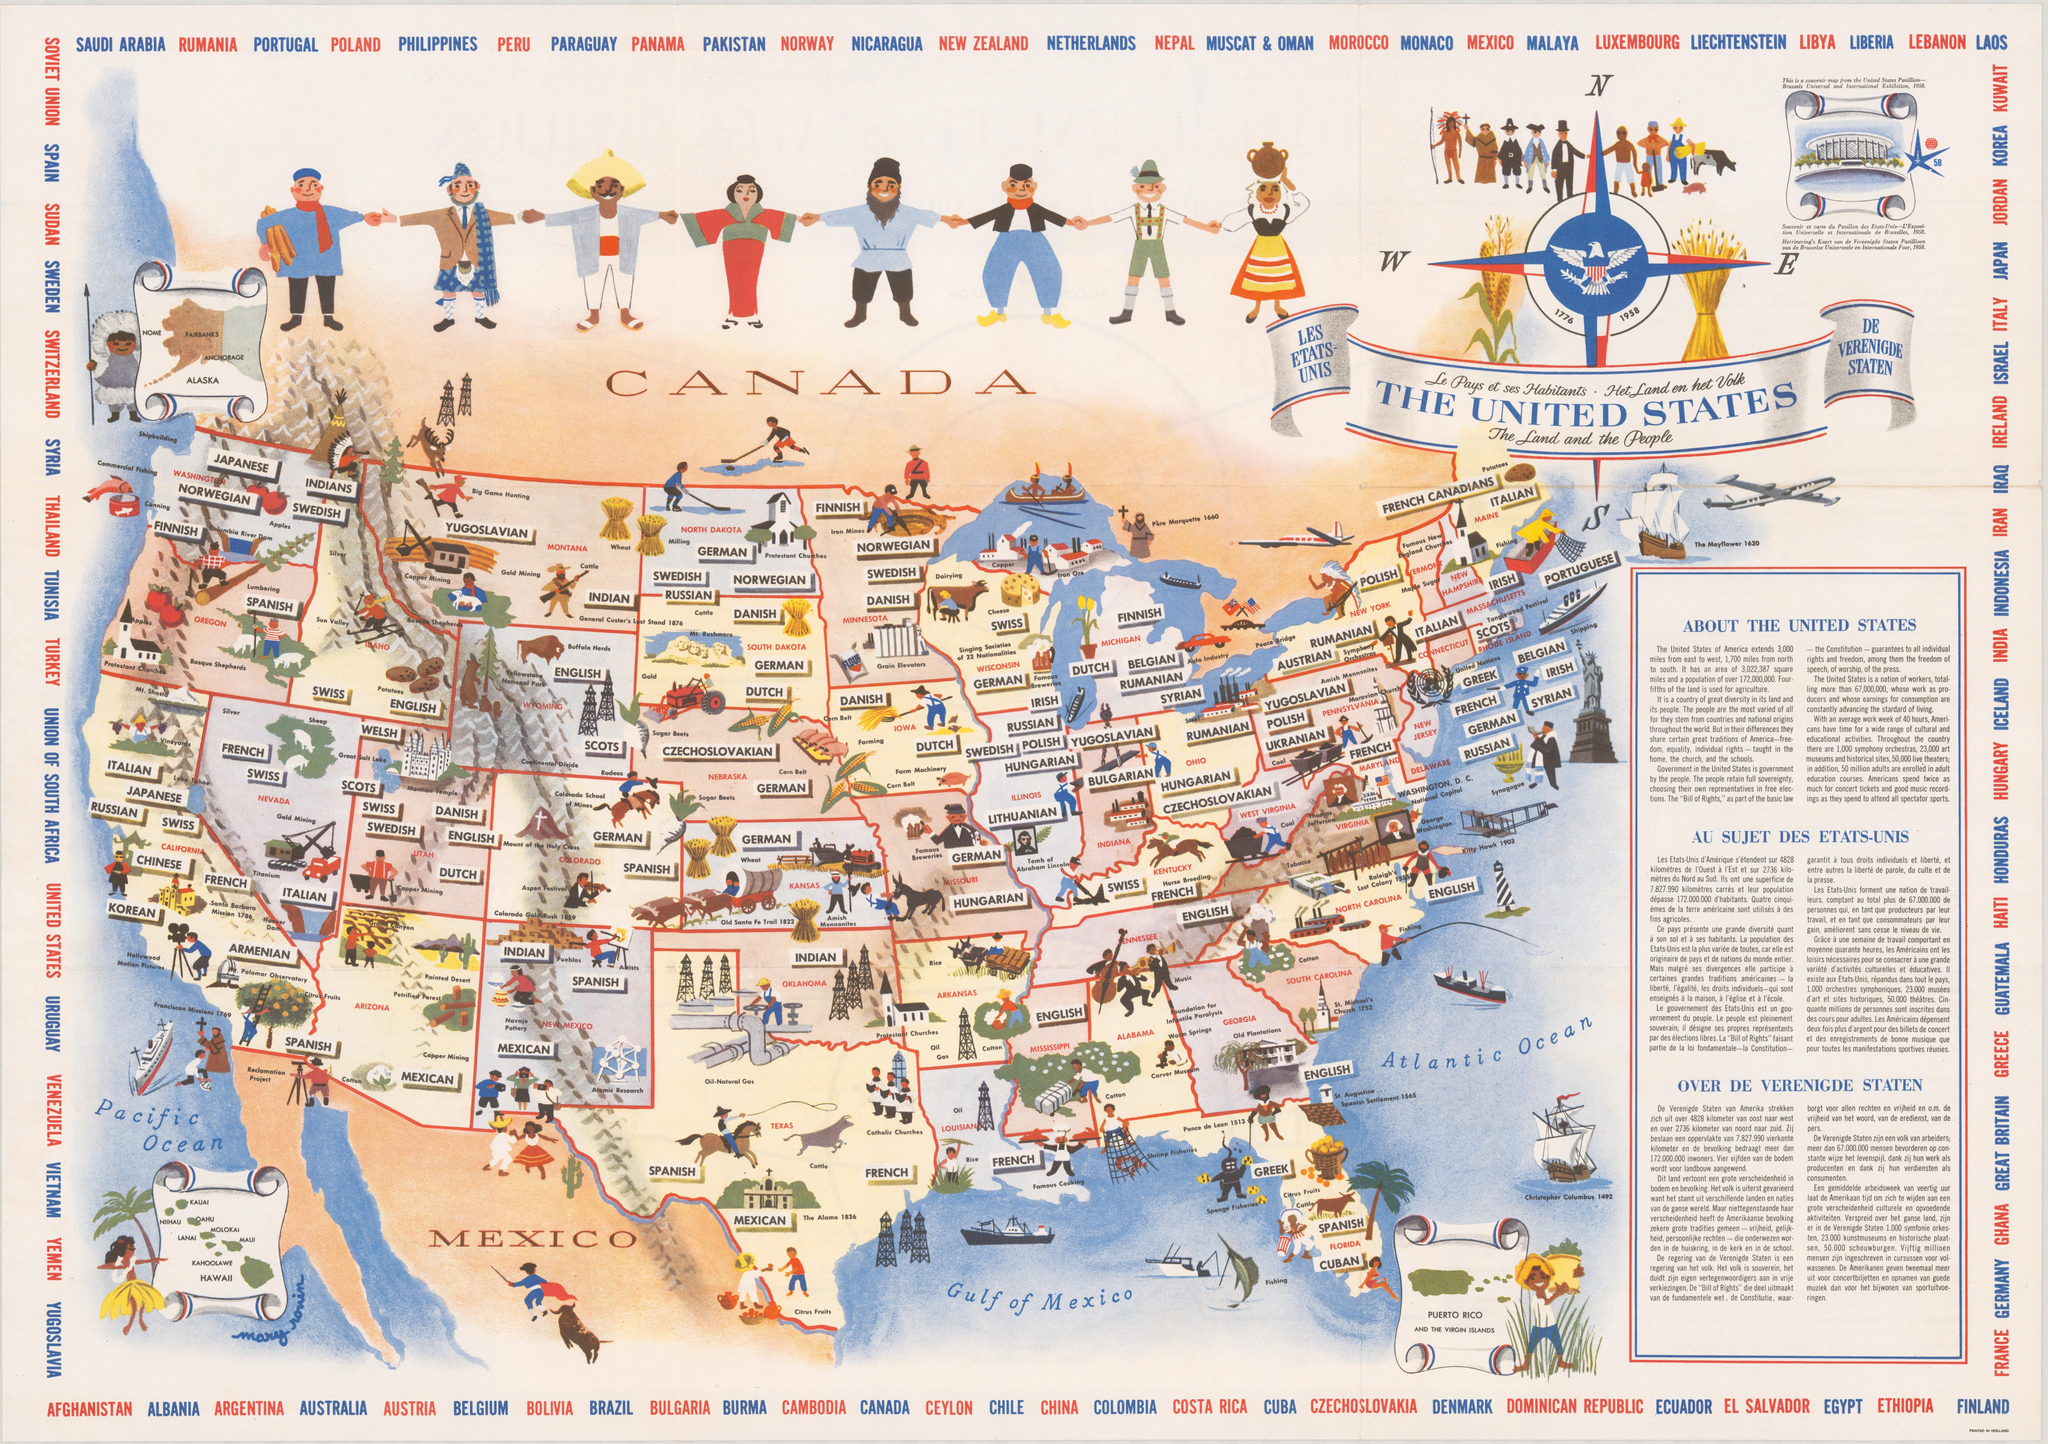In which state is the Columbia River Dam?
Answer the question with a short phrase. Washington In which state is Carver Museum is located? Alabama In which state is the Tomb of Abraham Lincoln? Illinois What type of mining is shown in the state of Arizona? Copper mining What is the north to south extent of USA? 1,700 miles In which state is St. Michael's church 1752? South Carolina What is the east to west extent of USA? 3,000 miles Which crop is grown in the state of Louisiana? Rice Which great traditions of America are shared by the people? freedom, equality, individual rights Which is the lake shown in the state of Utah? Great Salt Lake 